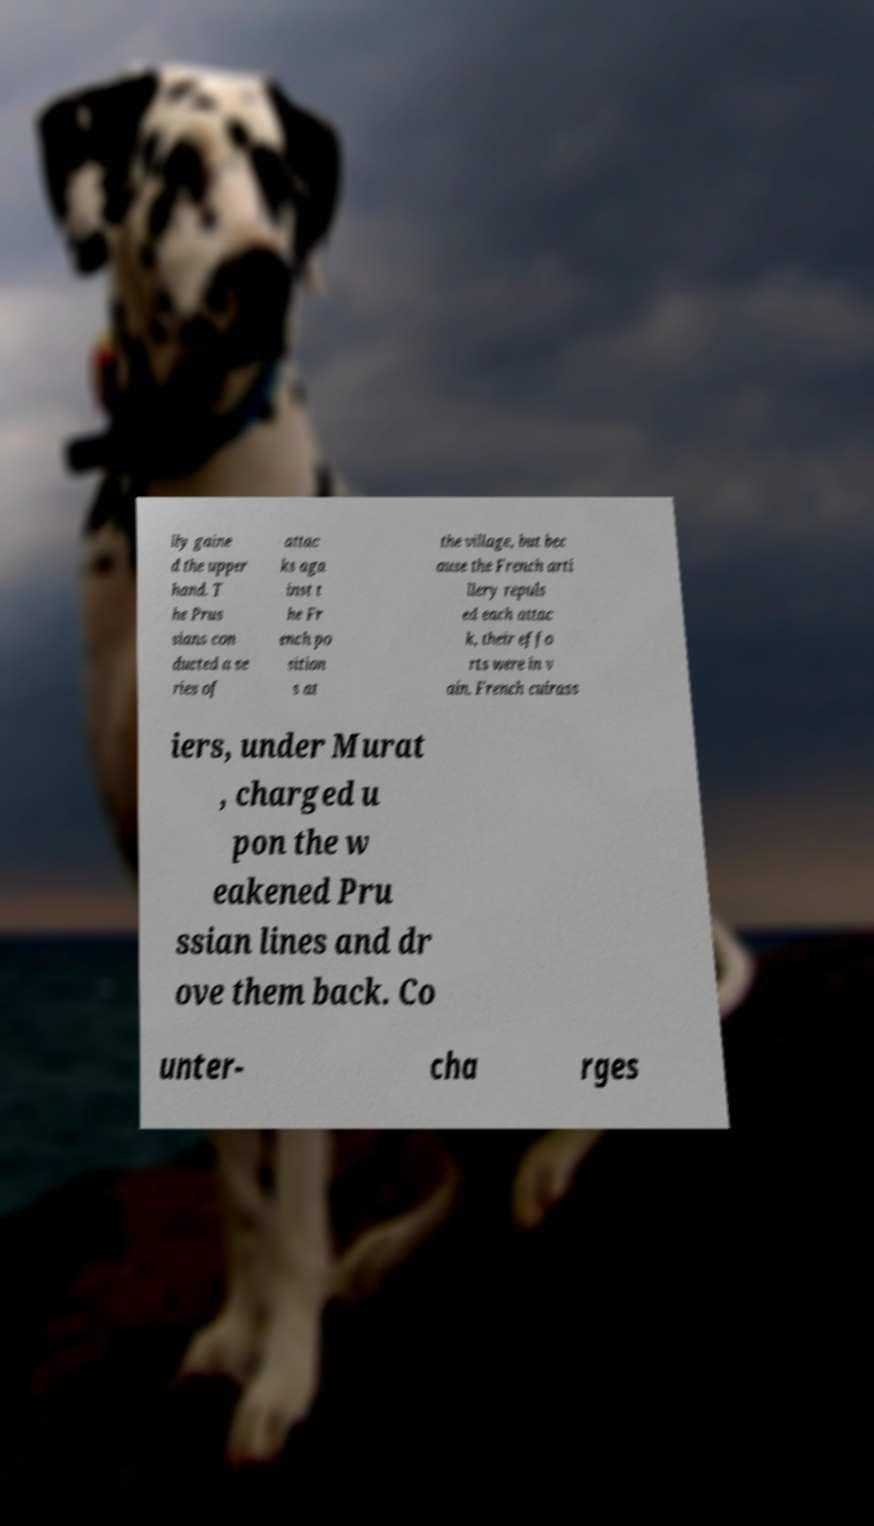There's text embedded in this image that I need extracted. Can you transcribe it verbatim? lly gaine d the upper hand. T he Prus sians con ducted a se ries of attac ks aga inst t he Fr ench po sition s at the village, but bec ause the French arti llery repuls ed each attac k, their effo rts were in v ain. French cuirass iers, under Murat , charged u pon the w eakened Pru ssian lines and dr ove them back. Co unter- cha rges 